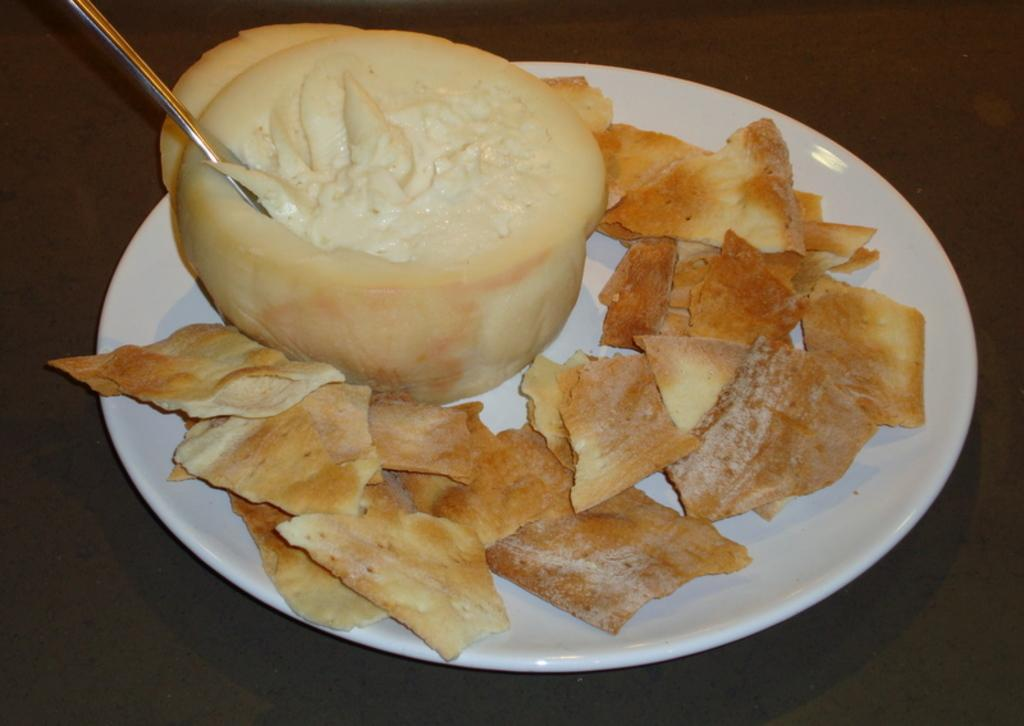What is on the plate that is visible in the image? There is a plate with food in the image. What utensil can be seen in the image? There is a spoon in the image. What might the food be placed on in the image? There is an object that looks like a table in the image. How many cows are grazing on the island in the image? There is no island or cows present in the image. What type of fruit is the pear on the table in the image? There is no pear present in the image. 